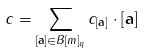<formula> <loc_0><loc_0><loc_500><loc_500>c = \sum _ { [ \mathbf a ] \in B [ m ] _ { q } } c _ { [ \mathbf a ] } \cdot [ \mathbf a ]</formula> 